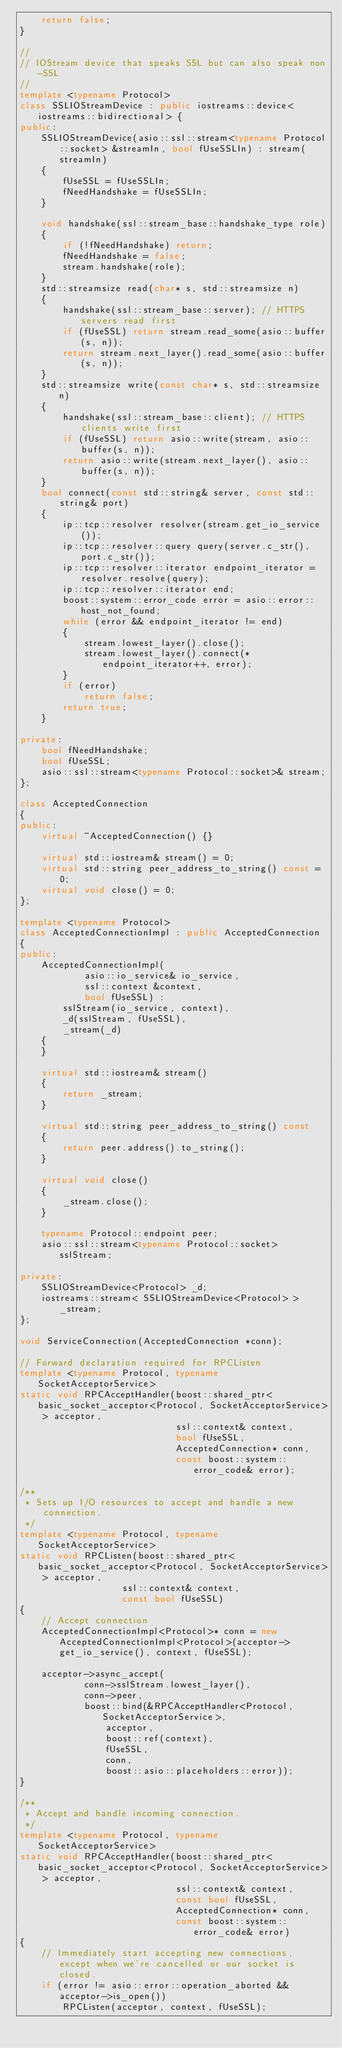Convert code to text. <code><loc_0><loc_0><loc_500><loc_500><_C++_>    return false;
}

//
// IOStream device that speaks SSL but can also speak non-SSL
//
template <typename Protocol>
class SSLIOStreamDevice : public iostreams::device<iostreams::bidirectional> {
public:
    SSLIOStreamDevice(asio::ssl::stream<typename Protocol::socket> &streamIn, bool fUseSSLIn) : stream(streamIn)
    {
        fUseSSL = fUseSSLIn;
        fNeedHandshake = fUseSSLIn;
    }

    void handshake(ssl::stream_base::handshake_type role)
    {
        if (!fNeedHandshake) return;
        fNeedHandshake = false;
        stream.handshake(role);
    }
    std::streamsize read(char* s, std::streamsize n)
    {
        handshake(ssl::stream_base::server); // HTTPS servers read first
        if (fUseSSL) return stream.read_some(asio::buffer(s, n));
        return stream.next_layer().read_some(asio::buffer(s, n));
    }
    std::streamsize write(const char* s, std::streamsize n)
    {
        handshake(ssl::stream_base::client); // HTTPS clients write first
        if (fUseSSL) return asio::write(stream, asio::buffer(s, n));
        return asio::write(stream.next_layer(), asio::buffer(s, n));
    }
    bool connect(const std::string& server, const std::string& port)
    {
        ip::tcp::resolver resolver(stream.get_io_service());
        ip::tcp::resolver::query query(server.c_str(), port.c_str());
        ip::tcp::resolver::iterator endpoint_iterator = resolver.resolve(query);
        ip::tcp::resolver::iterator end;
        boost::system::error_code error = asio::error::host_not_found;
        while (error && endpoint_iterator != end)
        {
            stream.lowest_layer().close();
            stream.lowest_layer().connect(*endpoint_iterator++, error);
        }
        if (error)
            return false;
        return true;
    }

private:
    bool fNeedHandshake;
    bool fUseSSL;
    asio::ssl::stream<typename Protocol::socket>& stream;
};

class AcceptedConnection
{
public:
    virtual ~AcceptedConnection() {}

    virtual std::iostream& stream() = 0;
    virtual std::string peer_address_to_string() const = 0;
    virtual void close() = 0;
};

template <typename Protocol>
class AcceptedConnectionImpl : public AcceptedConnection
{
public:
    AcceptedConnectionImpl(
            asio::io_service& io_service,
            ssl::context &context,
            bool fUseSSL) :
        sslStream(io_service, context),
        _d(sslStream, fUseSSL),
        _stream(_d)
    {
    }

    virtual std::iostream& stream()
    {
        return _stream;
    }

    virtual std::string peer_address_to_string() const
    {
        return peer.address().to_string();
    }

    virtual void close()
    {
        _stream.close();
    }

    typename Protocol::endpoint peer;
    asio::ssl::stream<typename Protocol::socket> sslStream;

private:
    SSLIOStreamDevice<Protocol> _d;
    iostreams::stream< SSLIOStreamDevice<Protocol> > _stream;
};

void ServiceConnection(AcceptedConnection *conn);

// Forward declaration required for RPCListen
template <typename Protocol, typename SocketAcceptorService>
static void RPCAcceptHandler(boost::shared_ptr< basic_socket_acceptor<Protocol, SocketAcceptorService> > acceptor,
                             ssl::context& context,
                             bool fUseSSL,
                             AcceptedConnection* conn,
                             const boost::system::error_code& error);

/**
 * Sets up I/O resources to accept and handle a new connection.
 */
template <typename Protocol, typename SocketAcceptorService>
static void RPCListen(boost::shared_ptr< basic_socket_acceptor<Protocol, SocketAcceptorService> > acceptor,
                   ssl::context& context,
                   const bool fUseSSL)
{
    // Accept connection
    AcceptedConnectionImpl<Protocol>* conn = new AcceptedConnectionImpl<Protocol>(acceptor->get_io_service(), context, fUseSSL);

    acceptor->async_accept(
            conn->sslStream.lowest_layer(),
            conn->peer,
            boost::bind(&RPCAcceptHandler<Protocol, SocketAcceptorService>,
                acceptor,
                boost::ref(context),
                fUseSSL,
                conn,
                boost::asio::placeholders::error));
}

/**
 * Accept and handle incoming connection.
 */
template <typename Protocol, typename SocketAcceptorService>
static void RPCAcceptHandler(boost::shared_ptr< basic_socket_acceptor<Protocol, SocketAcceptorService> > acceptor,
                             ssl::context& context,
                             const bool fUseSSL,
                             AcceptedConnection* conn,
                             const boost::system::error_code& error)
{
    // Immediately start accepting new connections, except when we're cancelled or our socket is closed.
    if (error != asio::error::operation_aborted && acceptor->is_open())
        RPCListen(acceptor, context, fUseSSL);
</code> 